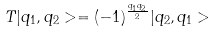<formula> <loc_0><loc_0><loc_500><loc_500>T | q _ { 1 } , q _ { 2 } > = ( - 1 ) ^ { \frac { q _ { 1 } q _ { 2 } } { 2 } } | q _ { 2 } , q _ { 1 } ></formula> 